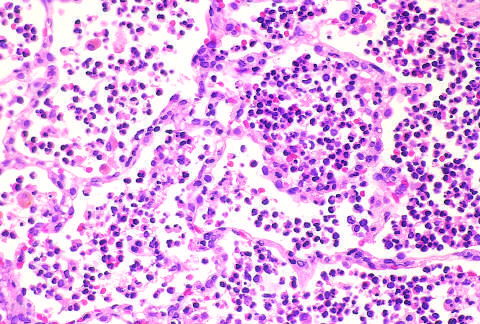have panels c and d not yet formed?
Answer the question using a single word or phrase. No 